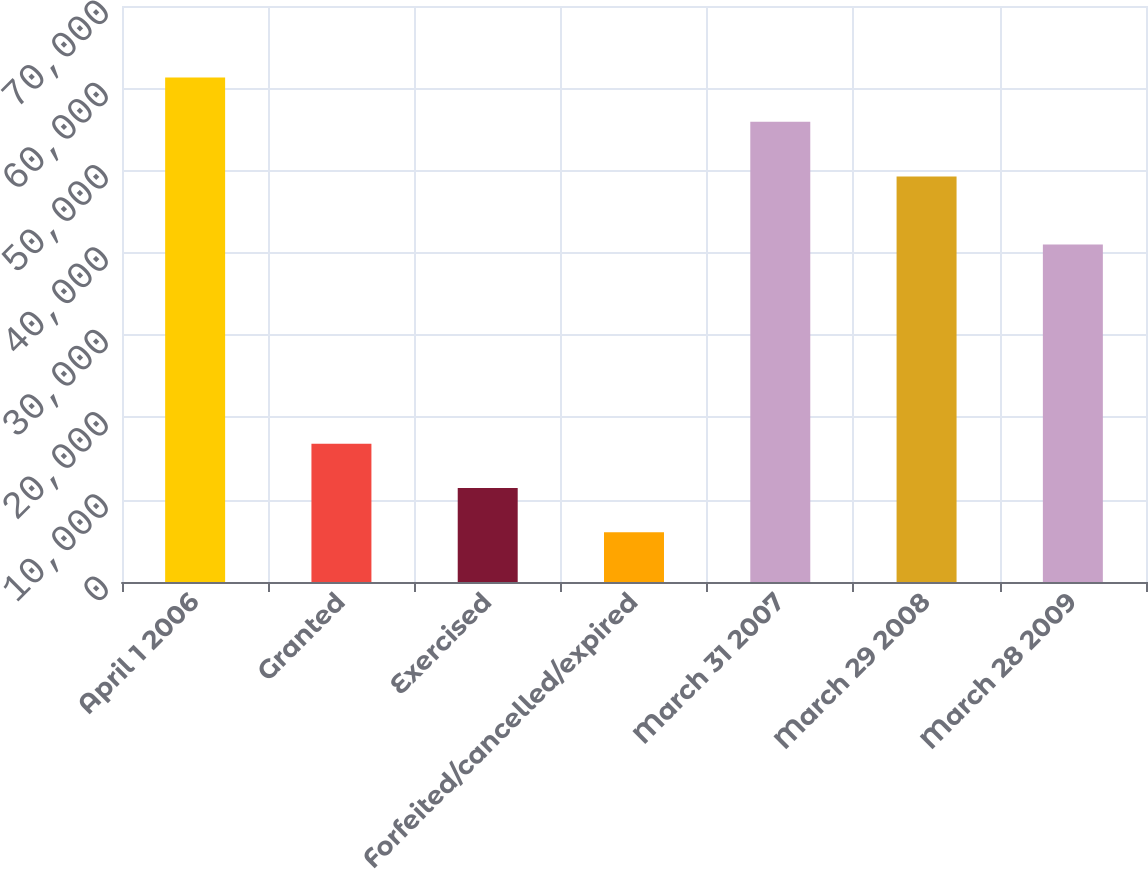<chart> <loc_0><loc_0><loc_500><loc_500><bar_chart><fcel>April 1 2006<fcel>Granted<fcel>Exercised<fcel>Forfeited/cancelled/expired<fcel>March 31 2007<fcel>March 29 2008<fcel>March 28 2009<nl><fcel>61320.9<fcel>16798.8<fcel>11419.9<fcel>6041<fcel>55942<fcel>49289<fcel>41021<nl></chart> 